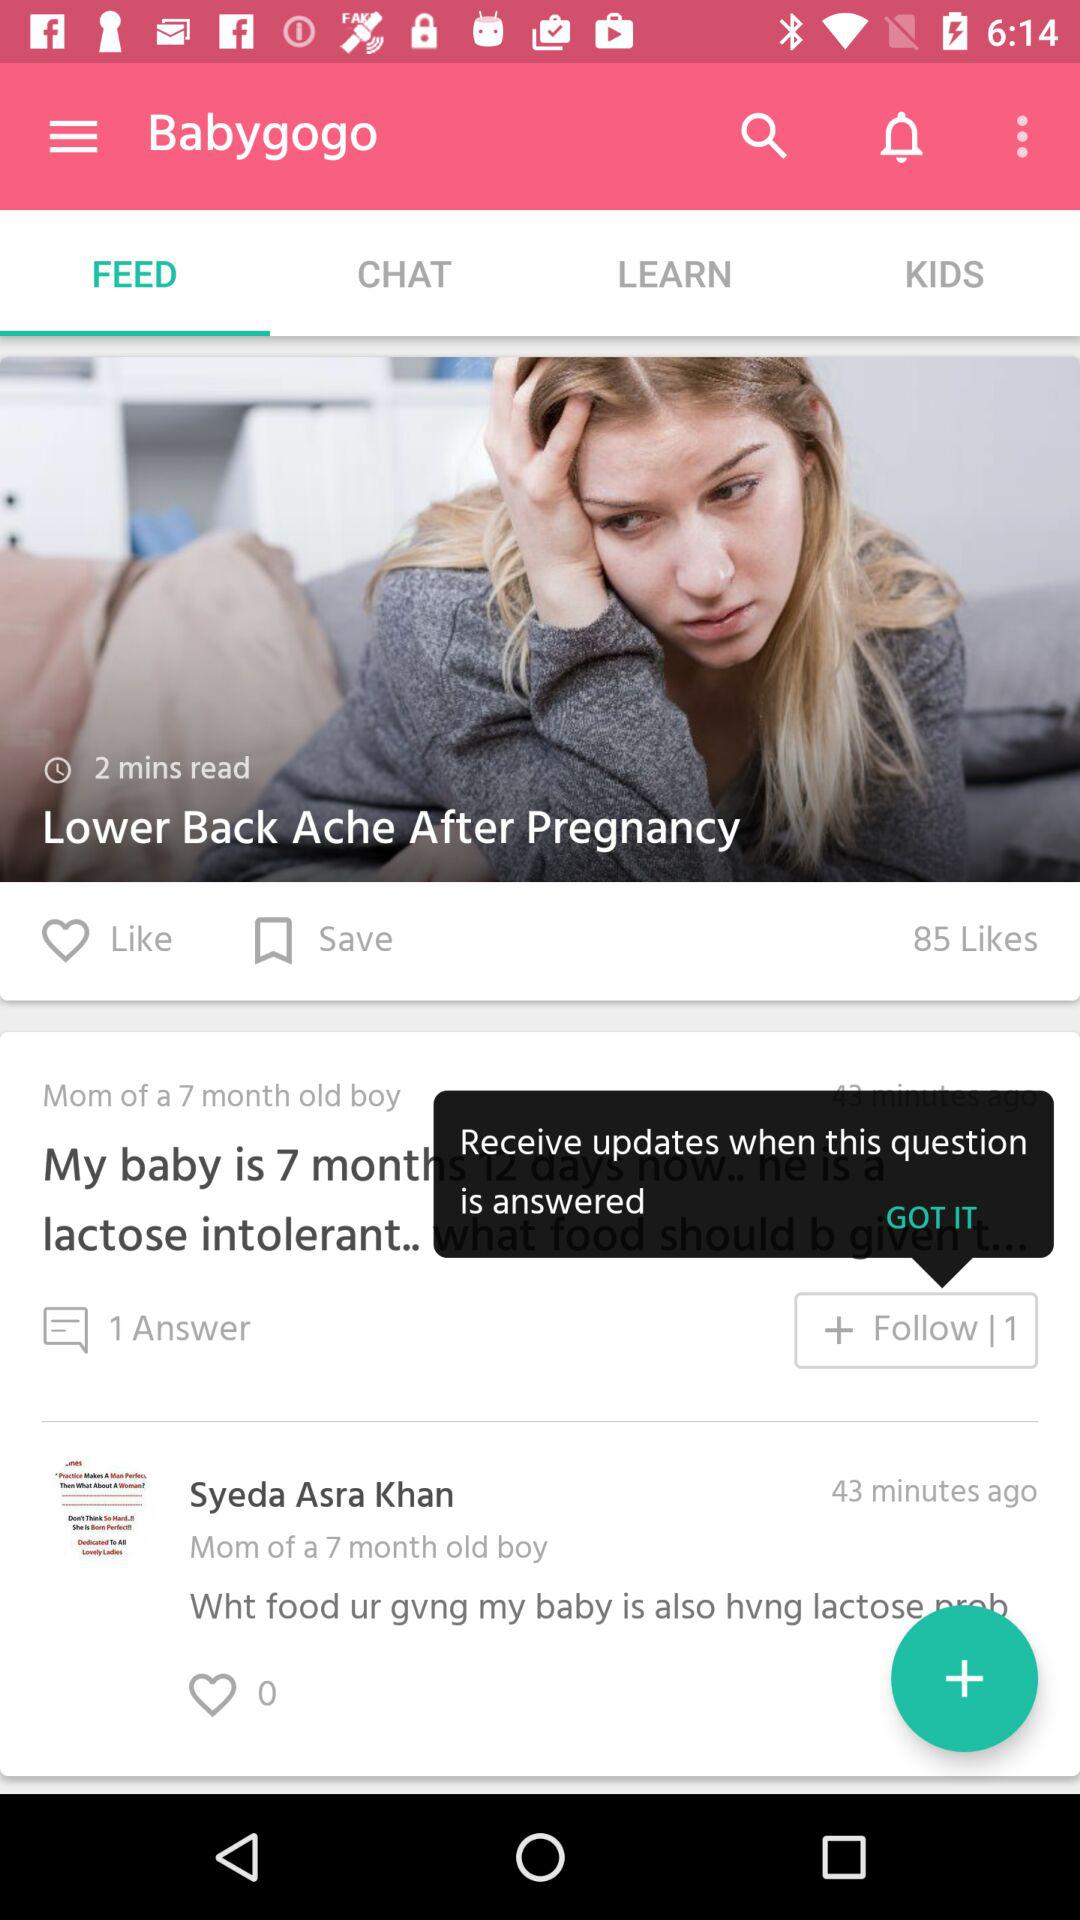What is the count for answers? The count for answers is one. 